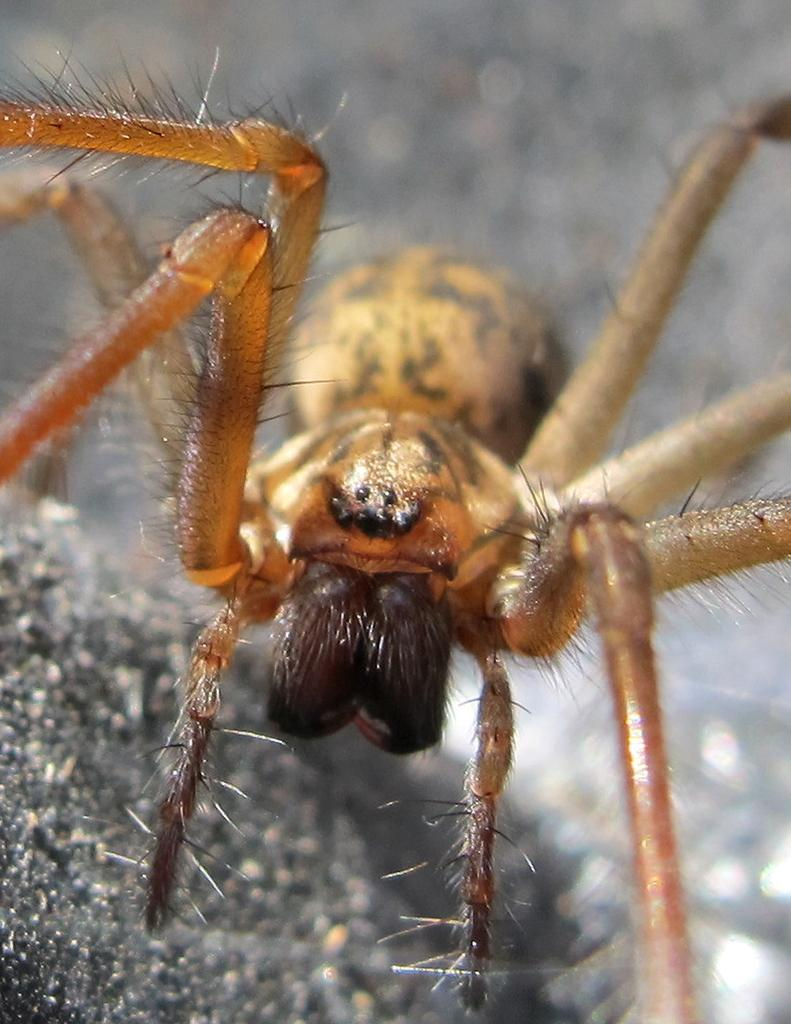What type of creature can be seen in the image? There is an insect in the image. Where is the insect located in the image? The insect is in the middle of the image. What type of partner does the insect have in the image? There is no partner present in the image; it only features the insect. 